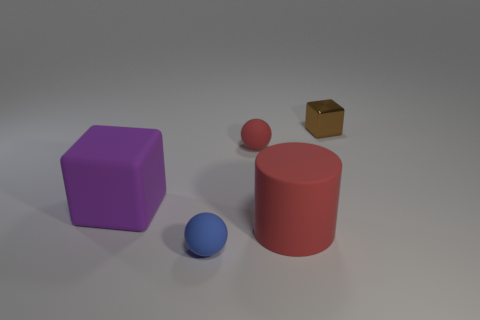Is there any other thing that has the same shape as the large red rubber thing?
Your answer should be compact. No. There is a rubber object that is the same size as the blue rubber sphere; what is its color?
Ensure brevity in your answer.  Red. What is the size of the blue rubber thing that is the same shape as the small red thing?
Make the answer very short. Small. The red rubber object in front of the small red rubber thing has what shape?
Your answer should be compact. Cylinder. There is a big purple matte object; is its shape the same as the brown object that is right of the large red object?
Ensure brevity in your answer.  Yes. Are there the same number of purple things that are in front of the large red rubber cylinder and purple things that are to the right of the tiny blue sphere?
Keep it short and to the point. Yes. The tiny matte thing that is the same color as the large rubber cylinder is what shape?
Ensure brevity in your answer.  Sphere. Does the matte object on the right side of the small red sphere have the same color as the ball that is in front of the purple thing?
Your answer should be very brief. No. Is the number of matte balls behind the matte block greater than the number of metallic things?
Make the answer very short. No. What material is the purple cube?
Provide a succinct answer. Rubber. 